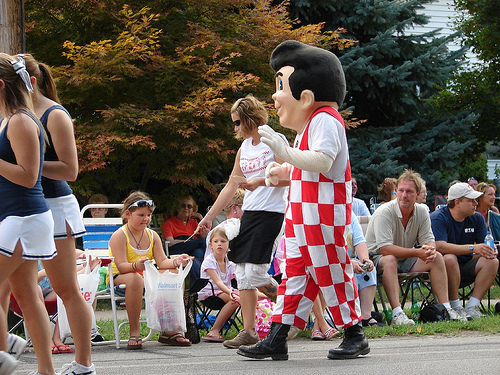<image>
Is the shoe next to the girl? No. The shoe is not positioned next to the girl. They are located in different areas of the scene. Is the bag above the ground? Yes. The bag is positioned above the ground in the vertical space, higher up in the scene. 